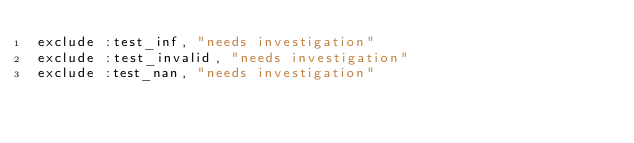Convert code to text. <code><loc_0><loc_0><loc_500><loc_500><_Ruby_>exclude :test_inf, "needs investigation"
exclude :test_invalid, "needs investigation"
exclude :test_nan, "needs investigation"
</code> 